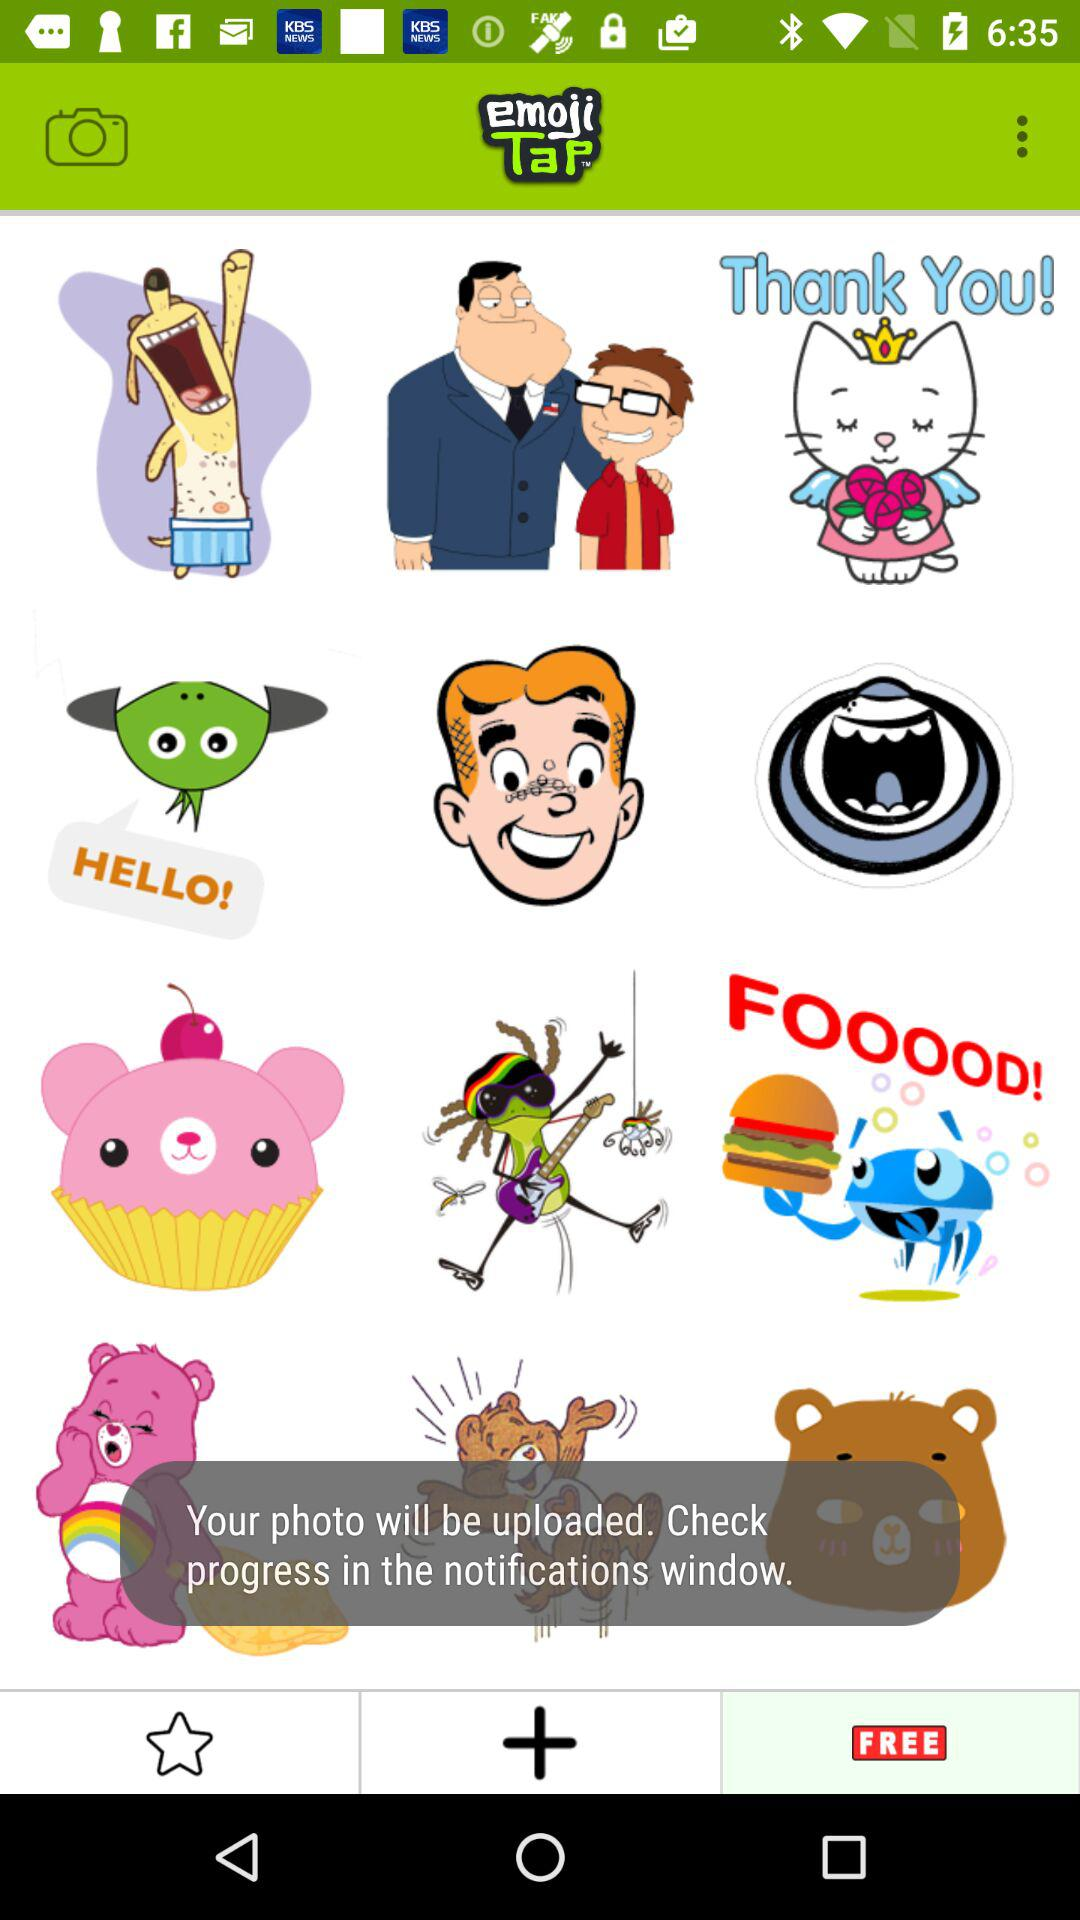What is the selected tab? The selected tab is "FREE". 